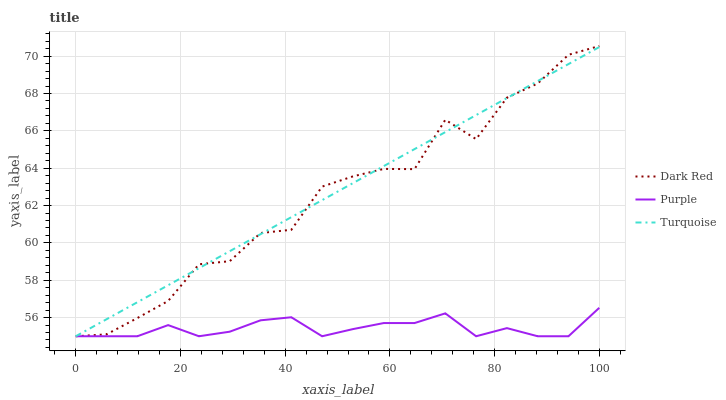Does Purple have the minimum area under the curve?
Answer yes or no. Yes. Does Turquoise have the maximum area under the curve?
Answer yes or no. Yes. Does Dark Red have the minimum area under the curve?
Answer yes or no. No. Does Dark Red have the maximum area under the curve?
Answer yes or no. No. Is Turquoise the smoothest?
Answer yes or no. Yes. Is Dark Red the roughest?
Answer yes or no. Yes. Is Dark Red the smoothest?
Answer yes or no. No. Is Turquoise the roughest?
Answer yes or no. No. Does Purple have the lowest value?
Answer yes or no. Yes. Does Dark Red have the highest value?
Answer yes or no. Yes. Does Turquoise have the highest value?
Answer yes or no. No. Does Dark Red intersect Turquoise?
Answer yes or no. Yes. Is Dark Red less than Turquoise?
Answer yes or no. No. Is Dark Red greater than Turquoise?
Answer yes or no. No. 